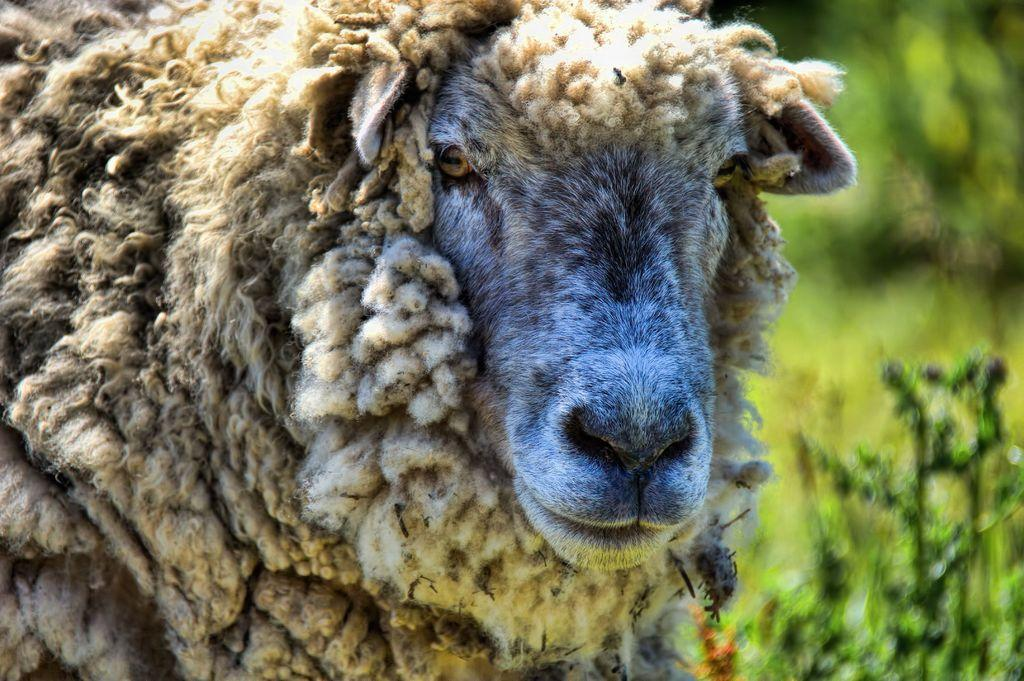What animal is present in the picture? There is a sheep in the picture. What type of vegetation can be seen on the right side of the picture? There are plants on the right side of the picture. What statement does the sheep make in the picture? Sheep do not make statements, as they are animals and do not have the ability to communicate through language. 